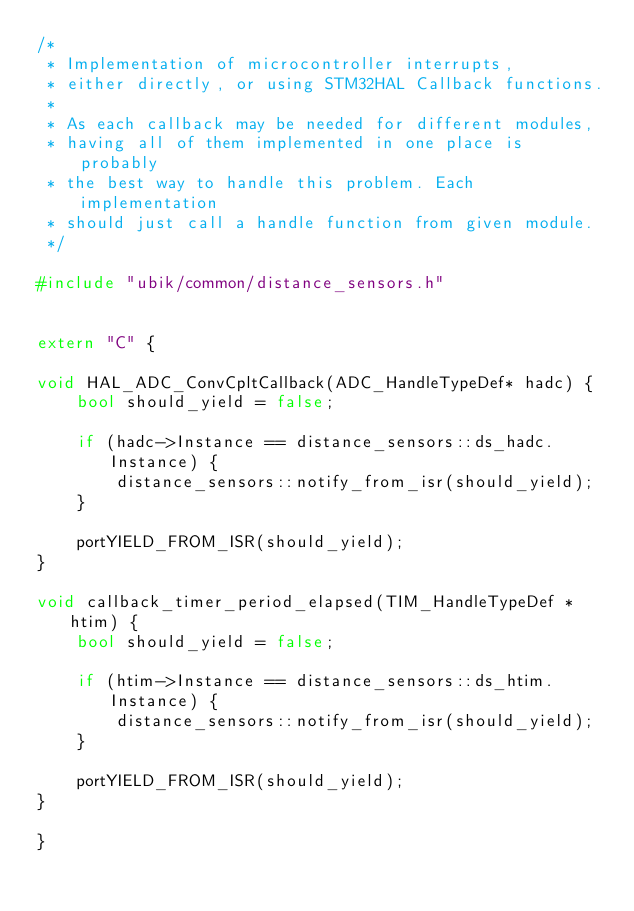<code> <loc_0><loc_0><loc_500><loc_500><_C++_>/*
 * Implementation of microcontroller interrupts,
 * either directly, or using STM32HAL Callback functions.
 *
 * As each callback may be needed for different modules,
 * having all of them implemented in one place is probably
 * the best way to handle this problem. Each implementation
 * should just call a handle function from given module.
 */

#include "ubik/common/distance_sensors.h"


extern "C" {

void HAL_ADC_ConvCpltCallback(ADC_HandleTypeDef* hadc) {
    bool should_yield = false;

    if (hadc->Instance == distance_sensors::ds_hadc.Instance) {
        distance_sensors::notify_from_isr(should_yield);
    }

    portYIELD_FROM_ISR(should_yield);
}

void callback_timer_period_elapsed(TIM_HandleTypeDef *htim) {
    bool should_yield = false;

    if (htim->Instance == distance_sensors::ds_htim.Instance) {
        distance_sensors::notify_from_isr(should_yield);
    }

    portYIELD_FROM_ISR(should_yield);
}

}

</code> 